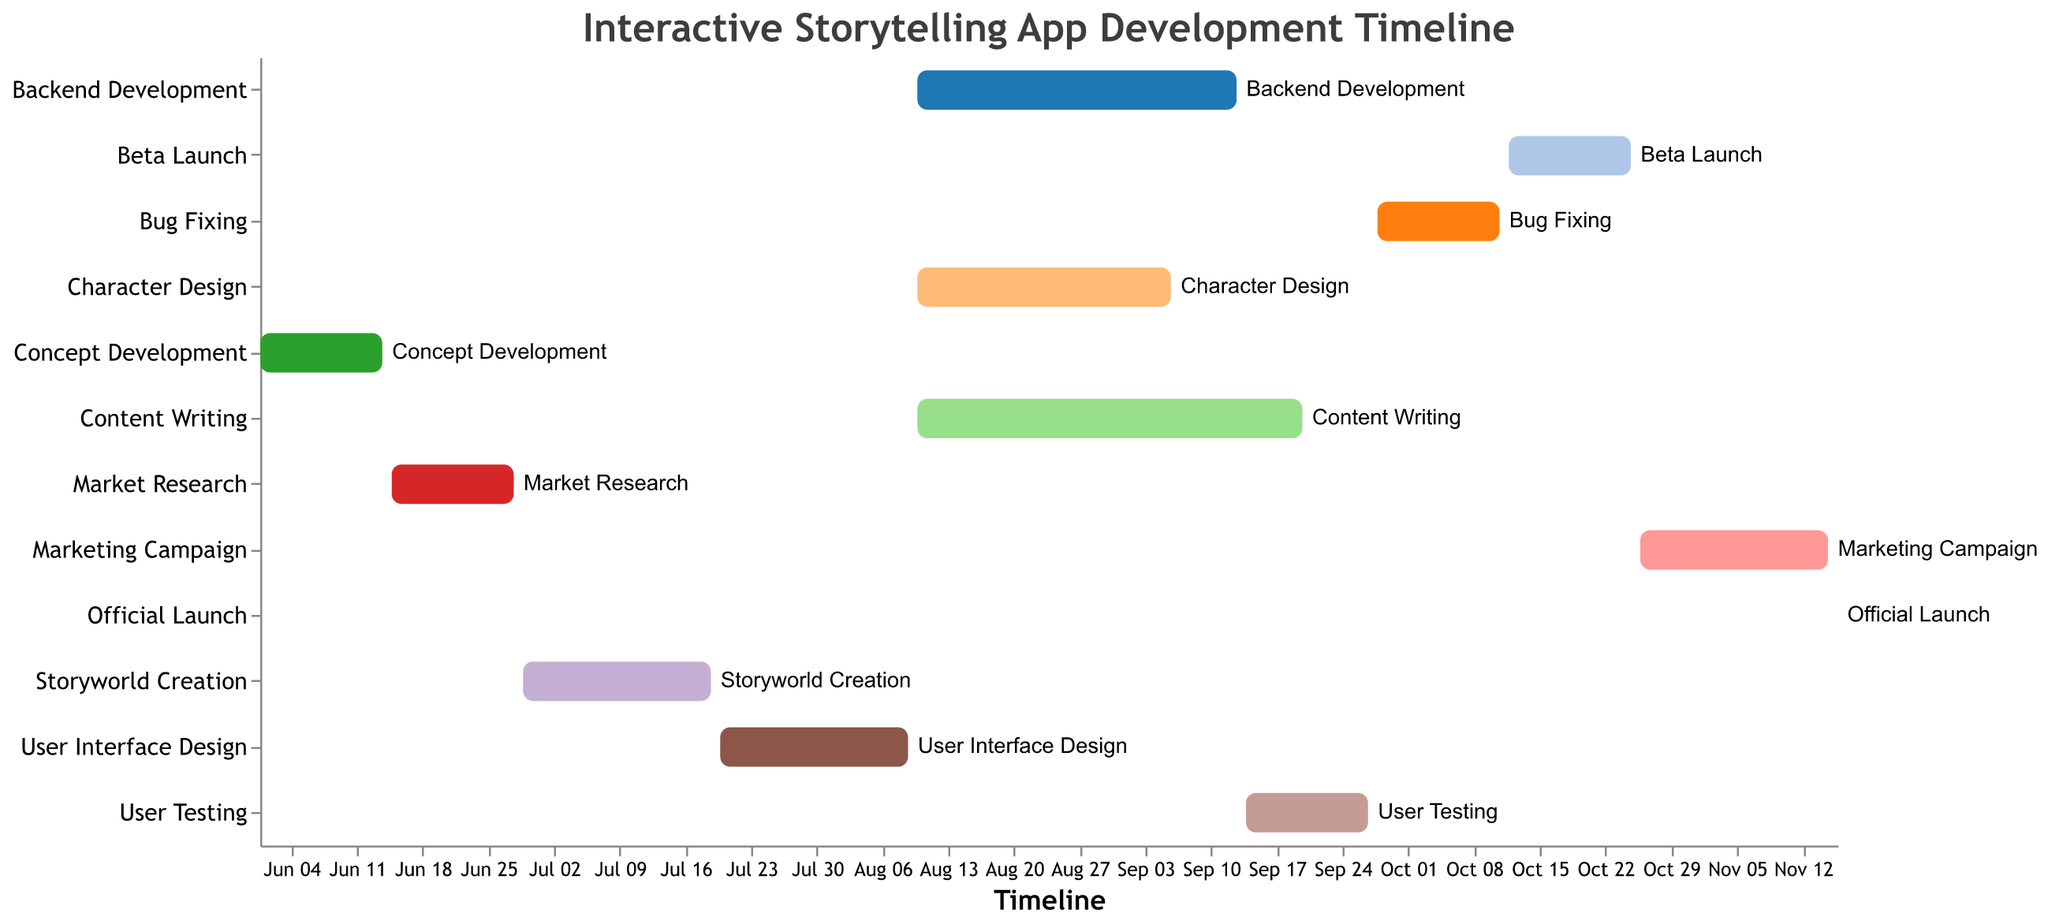What is the duration of the Backend Development task? The Gantt Chart shows that the Backend Development task starts on 2023-08-10 and ends on 2023-09-13, with the duration provided as 35 days.
Answer: 35 days When does the User Testing task begin and end? The Gantt Chart indicates that User Testing starts on 2023-09-14 and ends on 2023-09-27.
Answer: 2023-09-14 to 2023-09-27 How many days does the Bug Fixing task last? The Gantt Chart outlines that the Bug Fixing task begins on 2023-09-28 and finishes on 2023-10-11, lasting for 14 days.
Answer: 14 days Which task has the longest duration? Among all the tasks listed, Content Writing has the longest duration, lasting from 2023-08-10 to 2023-09-20, which is 42 days.
Answer: Content Writing What is the sequence of tasks starting from Storyworld Creation to Beta Launch? First, Storyworld Creation starts on 2023-06-29 and ends on 2023-07-19. Next is User Interface Design from 2023-07-20 to 2023-08-09. Backend Development, Content Writing, and Character Design all start on 2023-08-10, with Backend Development ending on 2023-09-13, Content Writing ending on 2023-09-20, and Character Design ending on 2023-09-06. User Testing follows from 2023-09-14 to 2023-09-27, then Bug Fixing from 2023-09-28 to 2023-10-11, and finally Beta Launch from 2023-10-12 to 2023-10-25.
Answer: Storyworld Creation -> User Interface Design -> Backend Development/Content Writing/Character Design -> User Testing -> Bug Fixing -> Beta Launch How many tasks overlap on the start date 2023-08-10? The Gantt Chart shows that Backend Development, Content Writing, and Character Design all begin on 2023-08-10.
Answer: 3 tasks Which task directly follows Market Research? Storyworld Creation starts on 2023-06-29, the day after Market Research ends on 2023-06-28.
Answer: Storyworld Creation Which two tasks have the shortest duration and how long are they? Both Concept Development and Bug Fixing have the shortest duration of 14 days each, from 2023-06-01 to 2023-06-14 and from 2023-09-28 to 2023-10-11 respectively.
Answer: Concept Development & Bug Fixing; 14 days each What occurs right after Bug Fixing? According to the Gantt Chart, Beta Launch follows immediately after Bug Fixing, starting on 2023-10-12 and ending on 2023-10-25.
Answer: Beta Launch When does the Marketing Campaign start, relative to the Official Launch? The Gantt Chart demonstrates that the Marketing Campaign starts on 2023-10-26 and ends on 2023-11-15, just one day before the Official Launch on 2023-11-16.
Answer: One day before the Official Launch 